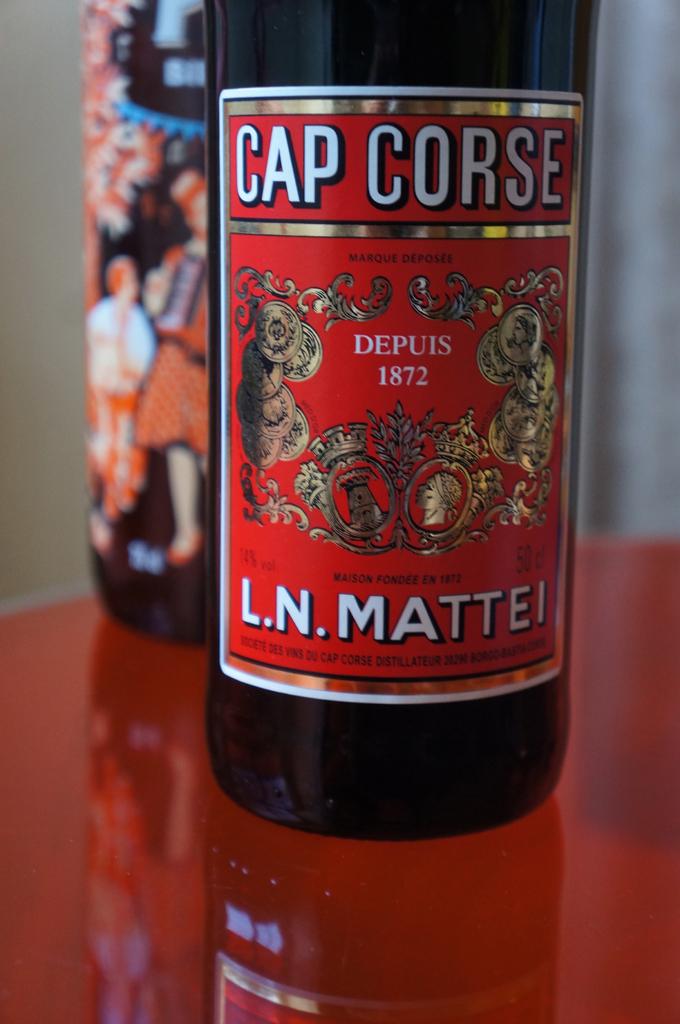What is the name of this wine?
Your answer should be very brief. Cap corse. 